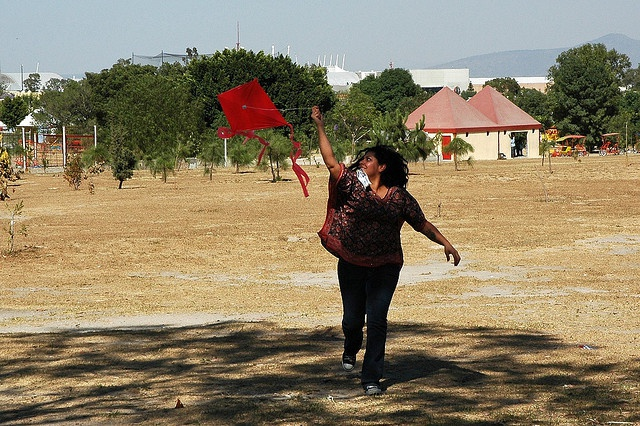Describe the objects in this image and their specific colors. I can see people in lightblue, black, maroon, darkgreen, and brown tones and kite in lightblue, maroon, black, and darkgreen tones in this image. 